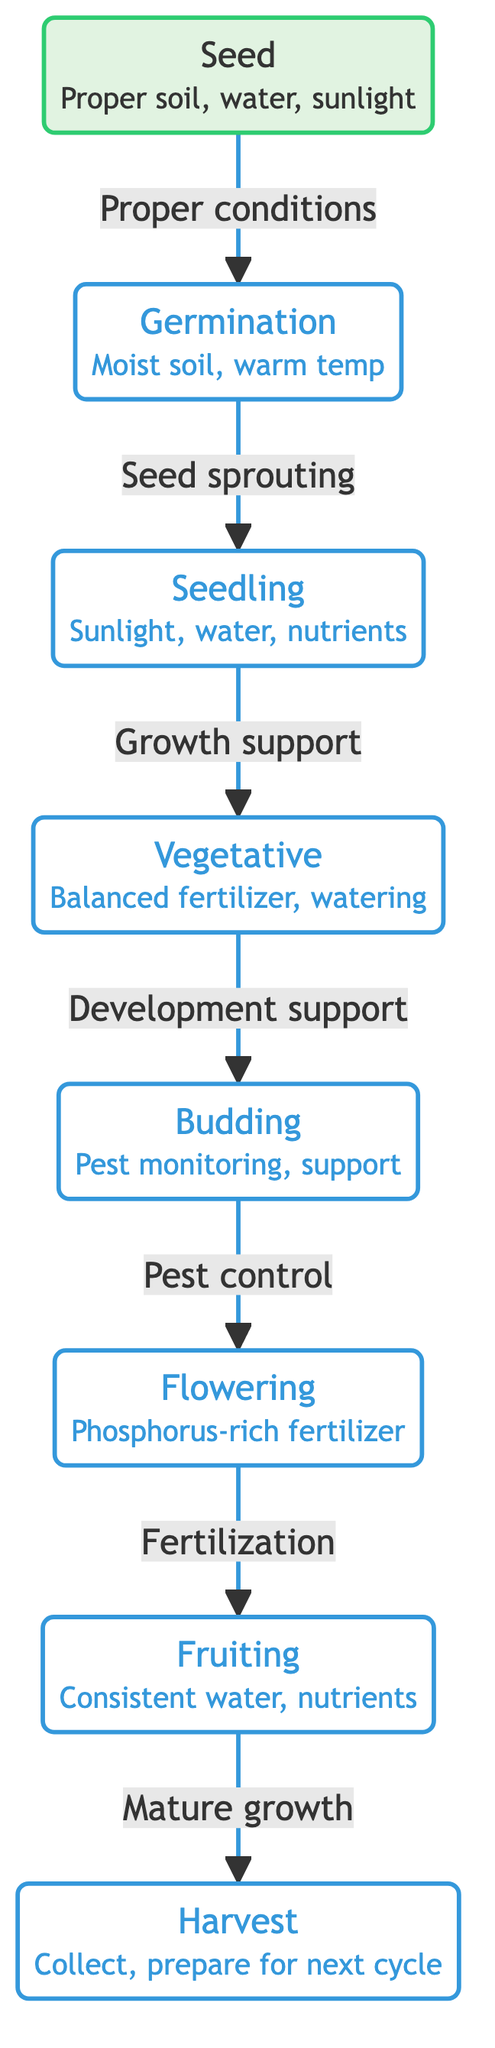What is the first stage of plant growth? The first stage depicted in the diagram is labeled "Seed."
Answer: Seed How many total stages are shown in the diagram? Counting all the stages from "Seed" to "Harvest," we find a total of 7 distinct stages.
Answer: 7 What is the necessary care during the Germination stage? The diagram indicates that the necessary care for the Germination stage includes "Moist soil, warm temp."
Answer: Moist soil, warm temp Which stage directly follows the Vegetative stage? Moving through the diagram, the stage that follows "Vegetative" is labeled "Budding."
Answer: Budding What is one of the necessary cares during the Flowering stage? According to the diagram, one crucial care needed during the Flowering stage is "Phosphorus-rich fertilizer."
Answer: Phosphorus-rich fertilizer Explain the transition from Seedling to Vegetative in the context of support. The diagram shows that the transition from "Seedling" to "Vegetative" is facilitated by "Growth support." This means that the plant requires specific conditions, such as nutrients and water, to successfully progress to the next growth stage.
Answer: Growth support What is the last stage of plant growth as illustrated? The final stage depicted in the diagram is "Harvest."
Answer: Harvest During which stage is pest monitoring necessary? The diagram specifies that pest monitoring is required during the "Budding" stage to ensure healthy plant development.
Answer: Budding What do you need to do after the Fruiting stage according to the diagram? After the "Fruiting" stage, the diagram instructs to "Collect, prepare for next cycle," indicating the actions required to conclude the plant growth process.
Answer: Collect, prepare for next cycle 